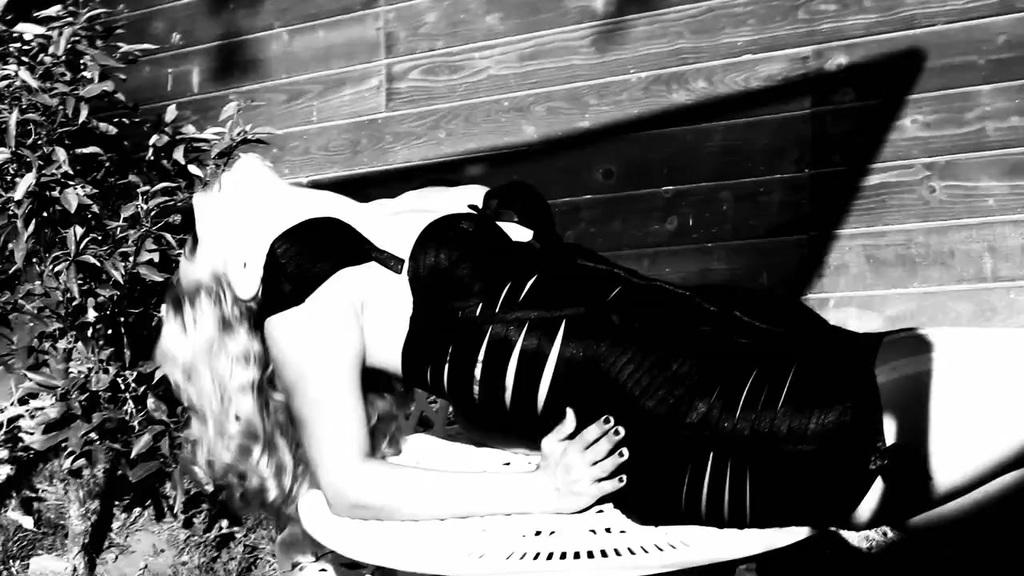What is the color scheme of the image? The image is black and white. Who is present in the image? There is a woman in the image. What is the woman wearing? The woman is wearing clothes. What is the woman's position in the image? The woman is lying down. What type of vegetation can be seen in the image? There are leaves visible in the image. What type of structure is present in the image? There is a wall in the image. What type of protest is taking place in the image? There is no protest present in the image; it features a woman lying down with leaves and a wall in the background. Can you provide an example of the produce visible in the image? There is no produce visible in the image; it is a black and white image with a woman, leaves, and a wall. 